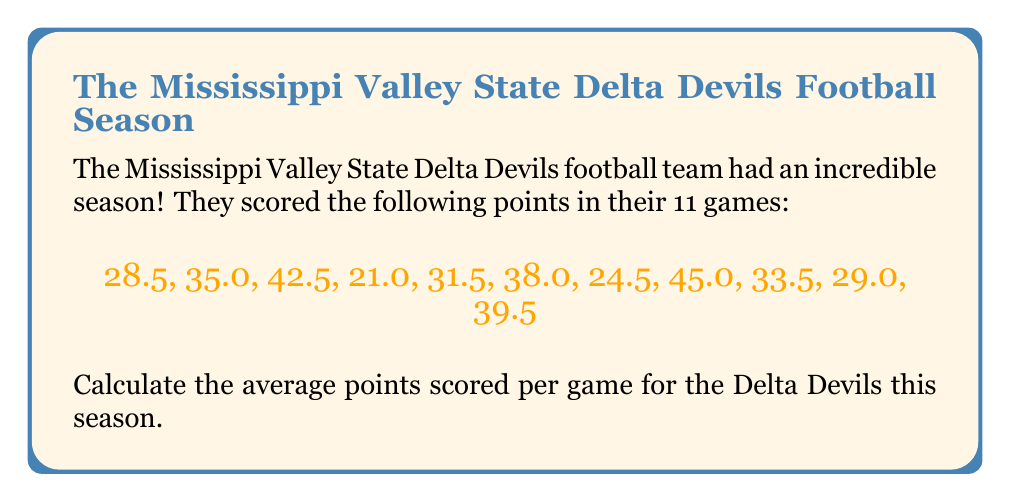What is the answer to this math problem? To calculate the average points scored per game, we need to follow these steps:

1. Sum up all the points scored:
   $$28.5 + 35.0 + 42.5 + 21.0 + 31.5 + 38.0 + 24.5 + 45.0 + 33.5 + 29.0 + 39.5$$

2. Add these numbers:
   $$\text{Total points} = 368.0$$

3. Count the number of games played:
   $$\text{Number of games} = 11$$

4. Use the formula for average:
   $$\text{Average} = \frac{\text{Sum of all values}}{\text{Number of values}}$$

5. Plug in our values:
   $$\text{Average points per game} = \frac{368.0}{11}$$

6. Perform the division:
   $$\text{Average points per game} = 33.45454545...$$

7. Round to two decimal places:
   $$\text{Average points per game} \approx 33.45$$
Answer: $33.45$ points per game 